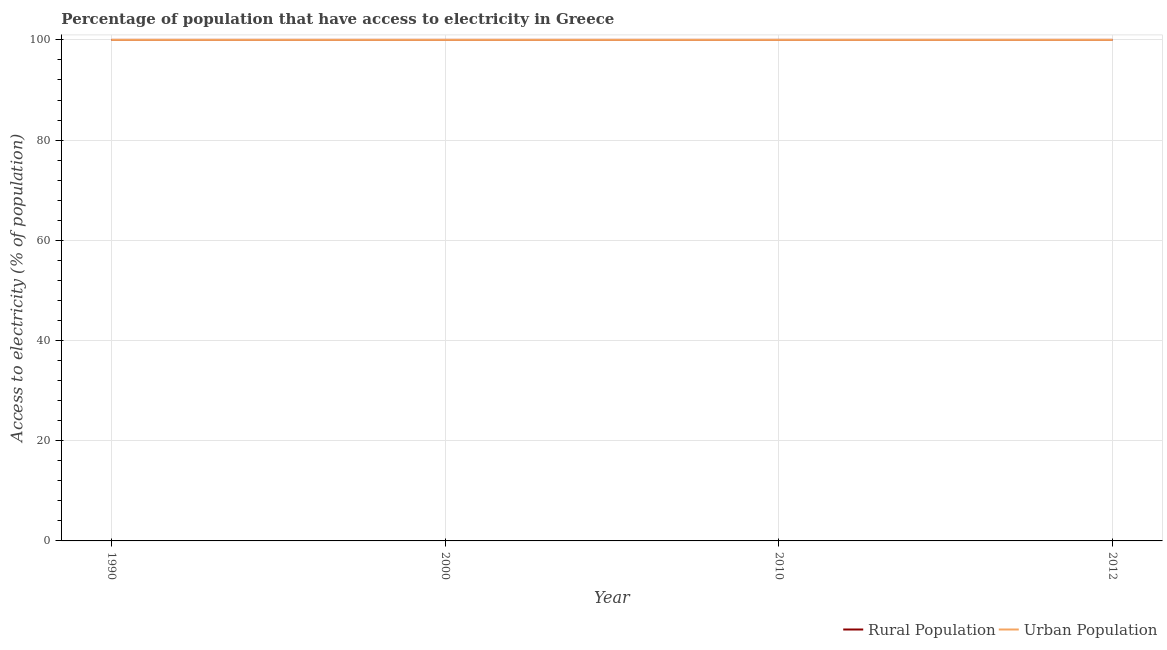How many different coloured lines are there?
Provide a succinct answer. 2. Does the line corresponding to percentage of rural population having access to electricity intersect with the line corresponding to percentage of urban population having access to electricity?
Keep it short and to the point. Yes. Is the number of lines equal to the number of legend labels?
Provide a succinct answer. Yes. What is the percentage of urban population having access to electricity in 2010?
Your answer should be very brief. 100. Across all years, what is the maximum percentage of rural population having access to electricity?
Give a very brief answer. 100. Across all years, what is the minimum percentage of urban population having access to electricity?
Keep it short and to the point. 100. In which year was the percentage of rural population having access to electricity minimum?
Your answer should be very brief. 1990. What is the total percentage of urban population having access to electricity in the graph?
Provide a short and direct response. 400. What is the difference between the percentage of rural population having access to electricity in 1990 and that in 2010?
Your answer should be compact. 0. What is the difference between the percentage of urban population having access to electricity in 2010 and the percentage of rural population having access to electricity in 1990?
Provide a short and direct response. 0. What is the average percentage of urban population having access to electricity per year?
Give a very brief answer. 100. In the year 2010, what is the difference between the percentage of rural population having access to electricity and percentage of urban population having access to electricity?
Offer a terse response. 0. Is the difference between the percentage of rural population having access to electricity in 1990 and 2012 greater than the difference between the percentage of urban population having access to electricity in 1990 and 2012?
Offer a very short reply. No. What is the difference between the highest and the second highest percentage of urban population having access to electricity?
Give a very brief answer. 0. In how many years, is the percentage of urban population having access to electricity greater than the average percentage of urban population having access to electricity taken over all years?
Keep it short and to the point. 0. Is the sum of the percentage of urban population having access to electricity in 2000 and 2012 greater than the maximum percentage of rural population having access to electricity across all years?
Ensure brevity in your answer.  Yes. Does the percentage of rural population having access to electricity monotonically increase over the years?
Ensure brevity in your answer.  No. Is the percentage of rural population having access to electricity strictly less than the percentage of urban population having access to electricity over the years?
Ensure brevity in your answer.  No. How many lines are there?
Make the answer very short. 2. How many years are there in the graph?
Give a very brief answer. 4. What is the difference between two consecutive major ticks on the Y-axis?
Your response must be concise. 20. Where does the legend appear in the graph?
Keep it short and to the point. Bottom right. How many legend labels are there?
Give a very brief answer. 2. How are the legend labels stacked?
Give a very brief answer. Horizontal. What is the title of the graph?
Provide a succinct answer. Percentage of population that have access to electricity in Greece. Does "Under-five" appear as one of the legend labels in the graph?
Your response must be concise. No. What is the label or title of the X-axis?
Your answer should be compact. Year. What is the label or title of the Y-axis?
Offer a very short reply. Access to electricity (% of population). What is the Access to electricity (% of population) in Urban Population in 1990?
Your answer should be very brief. 100. What is the Access to electricity (% of population) of Rural Population in 2000?
Ensure brevity in your answer.  100. What is the Access to electricity (% of population) in Urban Population in 2000?
Provide a short and direct response. 100. What is the Access to electricity (% of population) of Rural Population in 2010?
Offer a terse response. 100. What is the Access to electricity (% of population) in Rural Population in 2012?
Provide a succinct answer. 100. What is the Access to electricity (% of population) in Urban Population in 2012?
Ensure brevity in your answer.  100. Across all years, what is the maximum Access to electricity (% of population) in Urban Population?
Offer a terse response. 100. Across all years, what is the minimum Access to electricity (% of population) of Rural Population?
Provide a short and direct response. 100. Across all years, what is the minimum Access to electricity (% of population) in Urban Population?
Offer a very short reply. 100. What is the total Access to electricity (% of population) in Urban Population in the graph?
Offer a very short reply. 400. What is the difference between the Access to electricity (% of population) in Rural Population in 1990 and that in 2000?
Your response must be concise. 0. What is the difference between the Access to electricity (% of population) in Rural Population in 1990 and that in 2010?
Give a very brief answer. 0. What is the difference between the Access to electricity (% of population) in Rural Population in 2000 and that in 2010?
Offer a very short reply. 0. What is the difference between the Access to electricity (% of population) in Rural Population in 1990 and the Access to electricity (% of population) in Urban Population in 2010?
Provide a short and direct response. 0. What is the difference between the Access to electricity (% of population) of Rural Population in 2000 and the Access to electricity (% of population) of Urban Population in 2010?
Your answer should be compact. 0. In the year 1990, what is the difference between the Access to electricity (% of population) in Rural Population and Access to electricity (% of population) in Urban Population?
Offer a terse response. 0. In the year 2000, what is the difference between the Access to electricity (% of population) of Rural Population and Access to electricity (% of population) of Urban Population?
Ensure brevity in your answer.  0. In the year 2010, what is the difference between the Access to electricity (% of population) of Rural Population and Access to electricity (% of population) of Urban Population?
Give a very brief answer. 0. In the year 2012, what is the difference between the Access to electricity (% of population) of Rural Population and Access to electricity (% of population) of Urban Population?
Provide a succinct answer. 0. What is the ratio of the Access to electricity (% of population) in Rural Population in 1990 to that in 2000?
Provide a succinct answer. 1. What is the ratio of the Access to electricity (% of population) in Urban Population in 1990 to that in 2000?
Keep it short and to the point. 1. What is the ratio of the Access to electricity (% of population) of Rural Population in 1990 to that in 2010?
Your answer should be very brief. 1. What is the ratio of the Access to electricity (% of population) in Rural Population in 1990 to that in 2012?
Make the answer very short. 1. What is the ratio of the Access to electricity (% of population) of Urban Population in 2000 to that in 2010?
Offer a terse response. 1. What is the ratio of the Access to electricity (% of population) in Urban Population in 2000 to that in 2012?
Offer a terse response. 1. What is the ratio of the Access to electricity (% of population) in Urban Population in 2010 to that in 2012?
Provide a short and direct response. 1. What is the difference between the highest and the lowest Access to electricity (% of population) in Rural Population?
Make the answer very short. 0. 